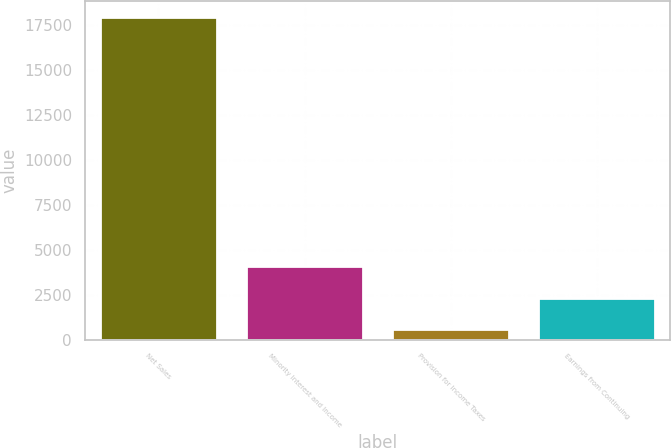Convert chart to OTSL. <chart><loc_0><loc_0><loc_500><loc_500><bar_chart><fcel>Net Sales<fcel>Minority Interest and Income<fcel>Provision for Income Taxes<fcel>Earnings from Continuing<nl><fcel>17914<fcel>4070.8<fcel>610<fcel>2340.4<nl></chart> 